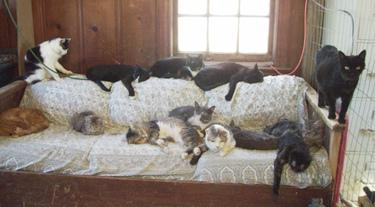What is the paneling made of which is covering the walls? wood 